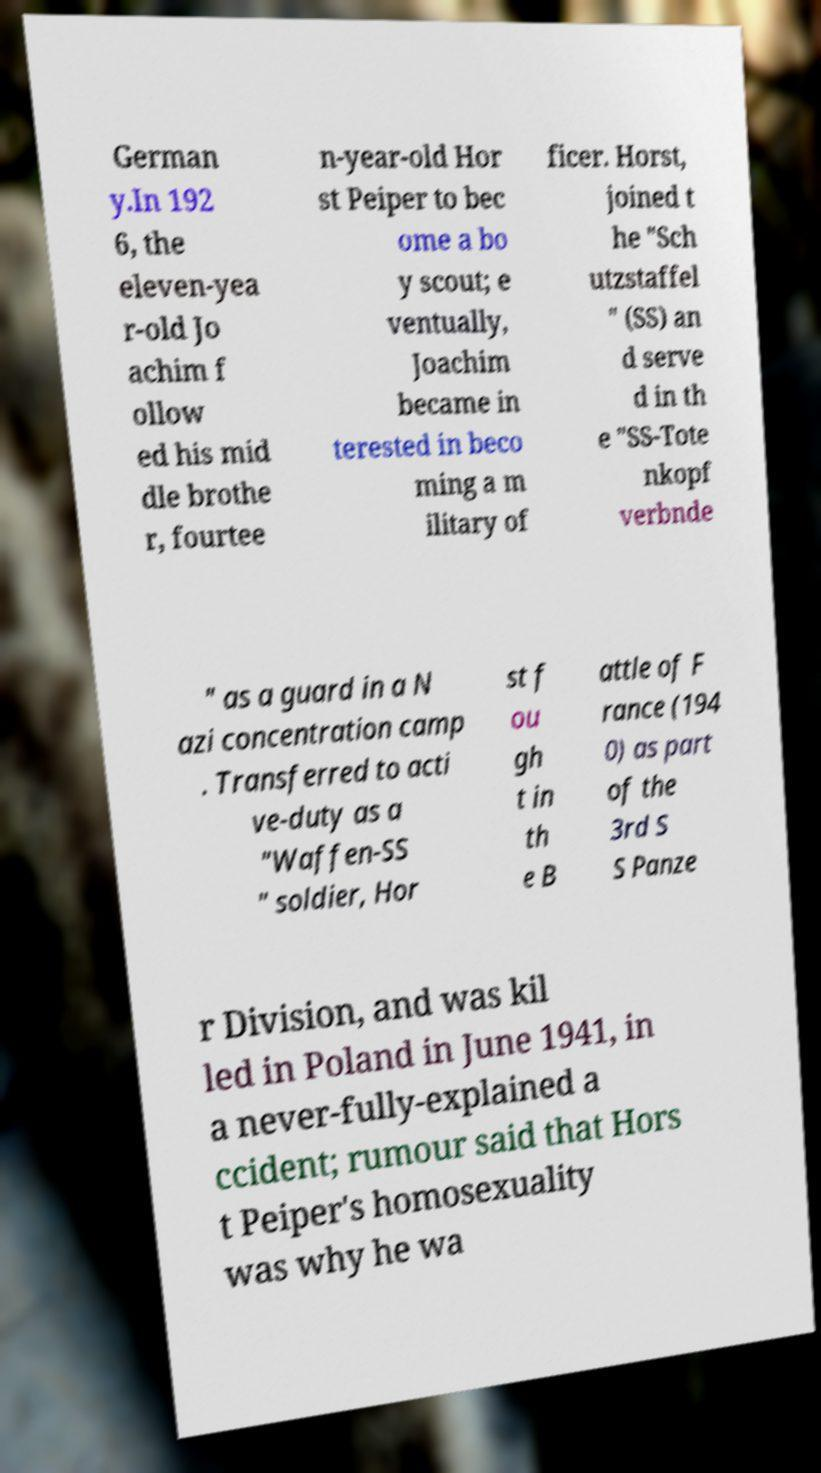What messages or text are displayed in this image? I need them in a readable, typed format. German y.In 192 6, the eleven-yea r-old Jo achim f ollow ed his mid dle brothe r, fourtee n-year-old Hor st Peiper to bec ome a bo y scout; e ventually, Joachim became in terested in beco ming a m ilitary of ficer. Horst, joined t he "Sch utzstaffel " (SS) an d serve d in th e "SS-Tote nkopf verbnde " as a guard in a N azi concentration camp . Transferred to acti ve-duty as a "Waffen-SS " soldier, Hor st f ou gh t in th e B attle of F rance (194 0) as part of the 3rd S S Panze r Division, and was kil led in Poland in June 1941, in a never-fully-explained a ccident; rumour said that Hors t Peiper's homosexuality was why he wa 